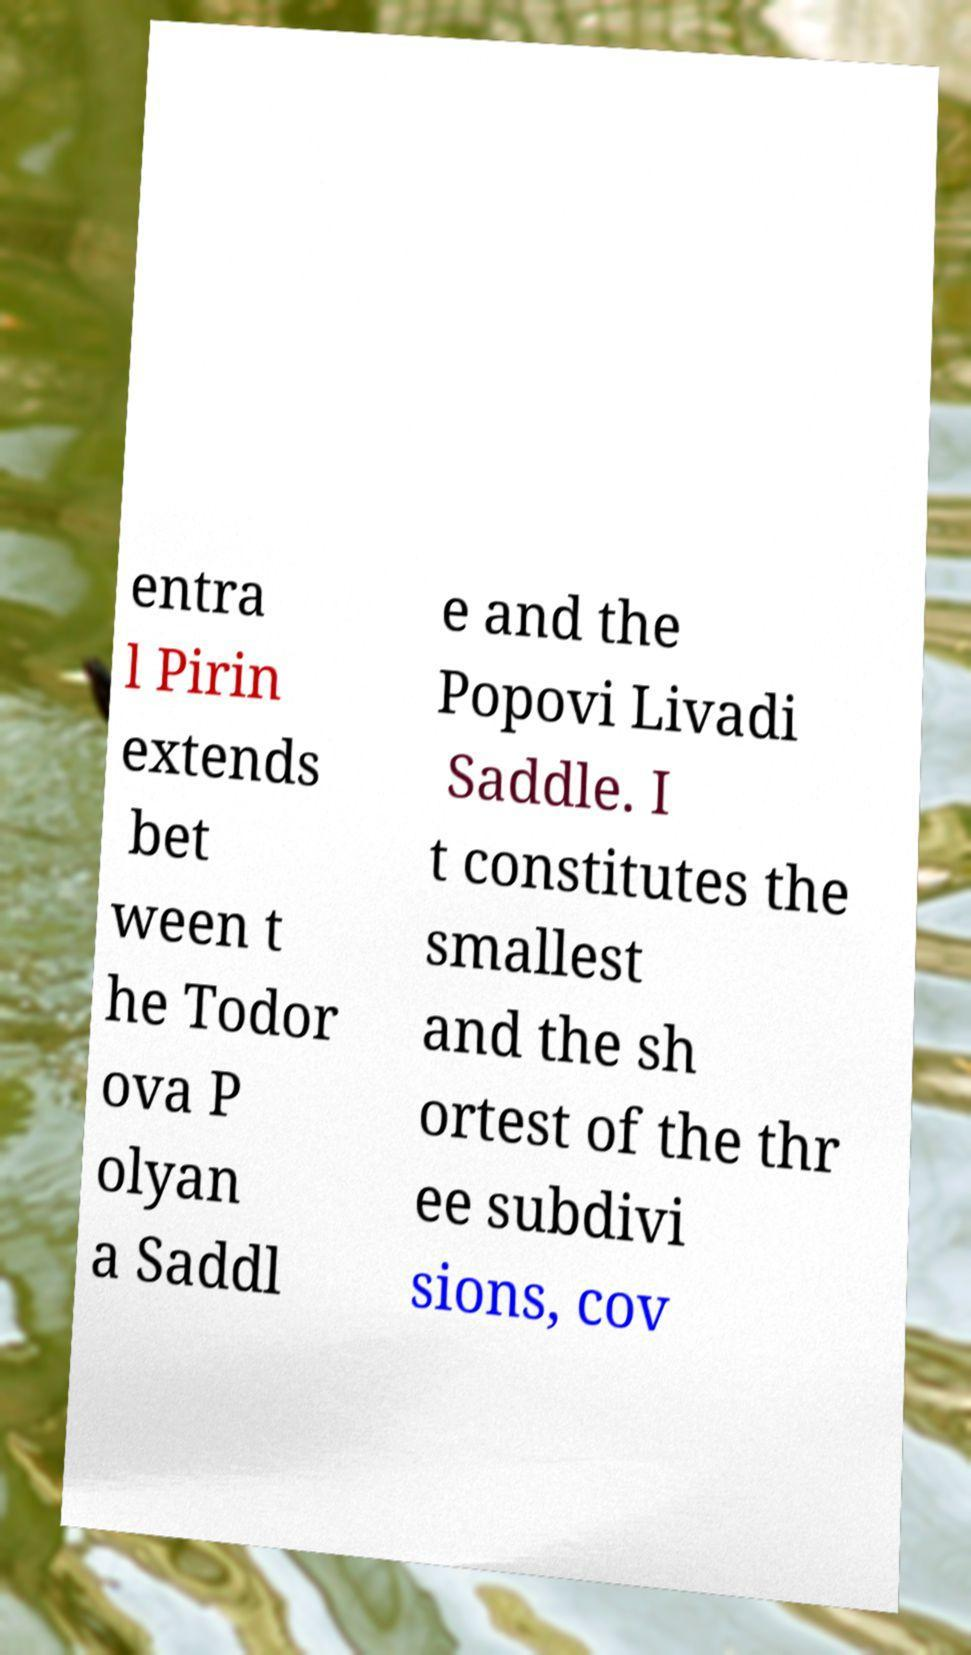Could you assist in decoding the text presented in this image and type it out clearly? entra l Pirin extends bet ween t he Todor ova P olyan a Saddl e and the Popovi Livadi Saddle. I t constitutes the smallest and the sh ortest of the thr ee subdivi sions, cov 